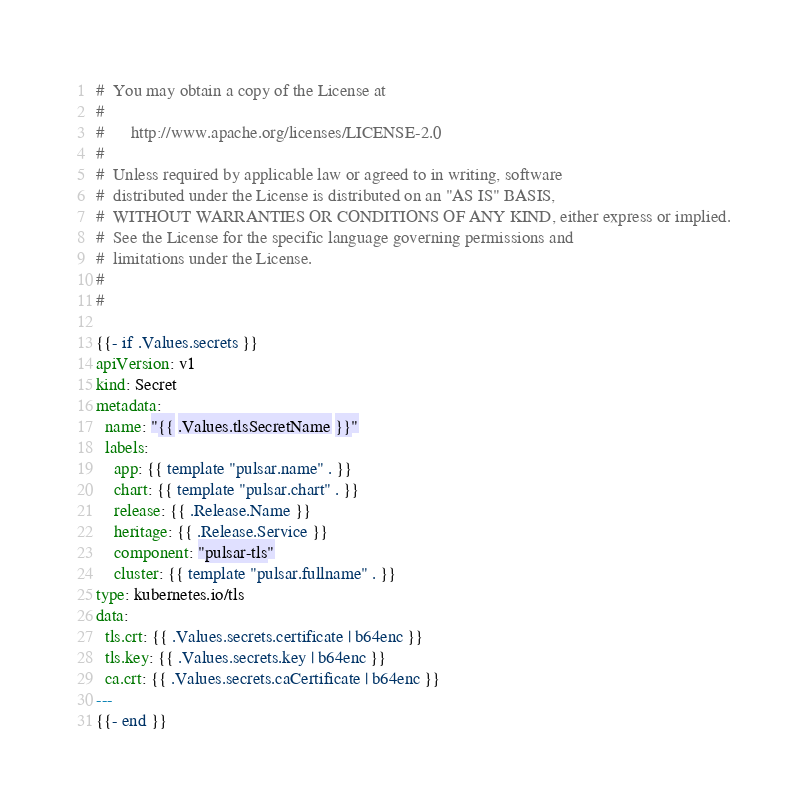<code> <loc_0><loc_0><loc_500><loc_500><_YAML_>#  You may obtain a copy of the License at
#
#      http://www.apache.org/licenses/LICENSE-2.0
#
#  Unless required by applicable law or agreed to in writing, software
#  distributed under the License is distributed on an "AS IS" BASIS,
#  WITHOUT WARRANTIES OR CONDITIONS OF ANY KIND, either express or implied.
#  See the License for the specific language governing permissions and
#  limitations under the License.
#
#

{{- if .Values.secrets }}
apiVersion: v1
kind: Secret
metadata:
  name: "{{ .Values.tlsSecretName }}"
  labels:
    app: {{ template "pulsar.name" . }}
    chart: {{ template "pulsar.chart" . }}
    release: {{ .Release.Name }}
    heritage: {{ .Release.Service }}
    component: "pulsar-tls"
    cluster: {{ template "pulsar.fullname" . }}
type: kubernetes.io/tls
data:
  tls.crt: {{ .Values.secrets.certificate | b64enc }}
  tls.key: {{ .Values.secrets.key | b64enc }}
  ca.crt: {{ .Values.secrets.caCertificate | b64enc }}
---
{{- end }}</code> 